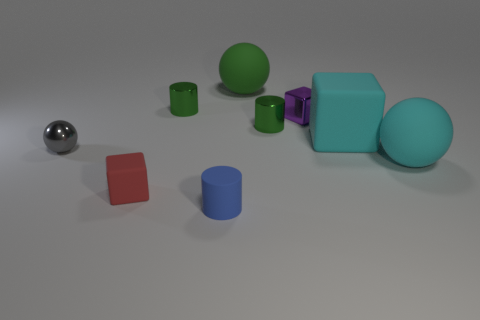Add 1 blocks. How many objects exist? 10 Subtract all cubes. How many objects are left? 6 Subtract 0 gray blocks. How many objects are left? 9 Subtract all red cubes. Subtract all tiny green shiny objects. How many objects are left? 6 Add 7 cyan cubes. How many cyan cubes are left? 8 Add 7 brown cylinders. How many brown cylinders exist? 7 